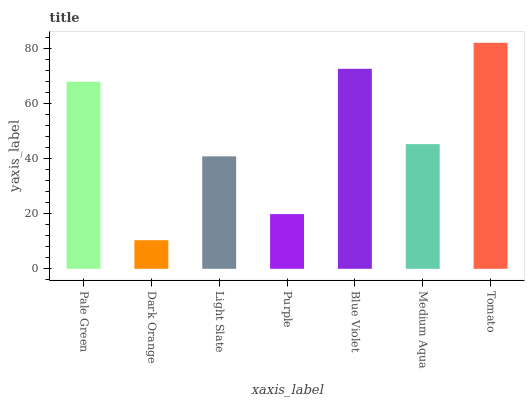Is Light Slate the minimum?
Answer yes or no. No. Is Light Slate the maximum?
Answer yes or no. No. Is Light Slate greater than Dark Orange?
Answer yes or no. Yes. Is Dark Orange less than Light Slate?
Answer yes or no. Yes. Is Dark Orange greater than Light Slate?
Answer yes or no. No. Is Light Slate less than Dark Orange?
Answer yes or no. No. Is Medium Aqua the high median?
Answer yes or no. Yes. Is Medium Aqua the low median?
Answer yes or no. Yes. Is Blue Violet the high median?
Answer yes or no. No. Is Purple the low median?
Answer yes or no. No. 